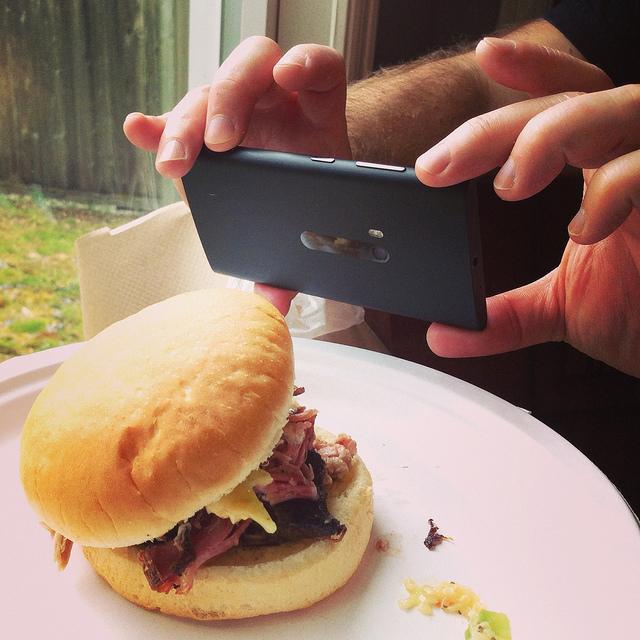How many tracks have trains on them?
Give a very brief answer. 0. 